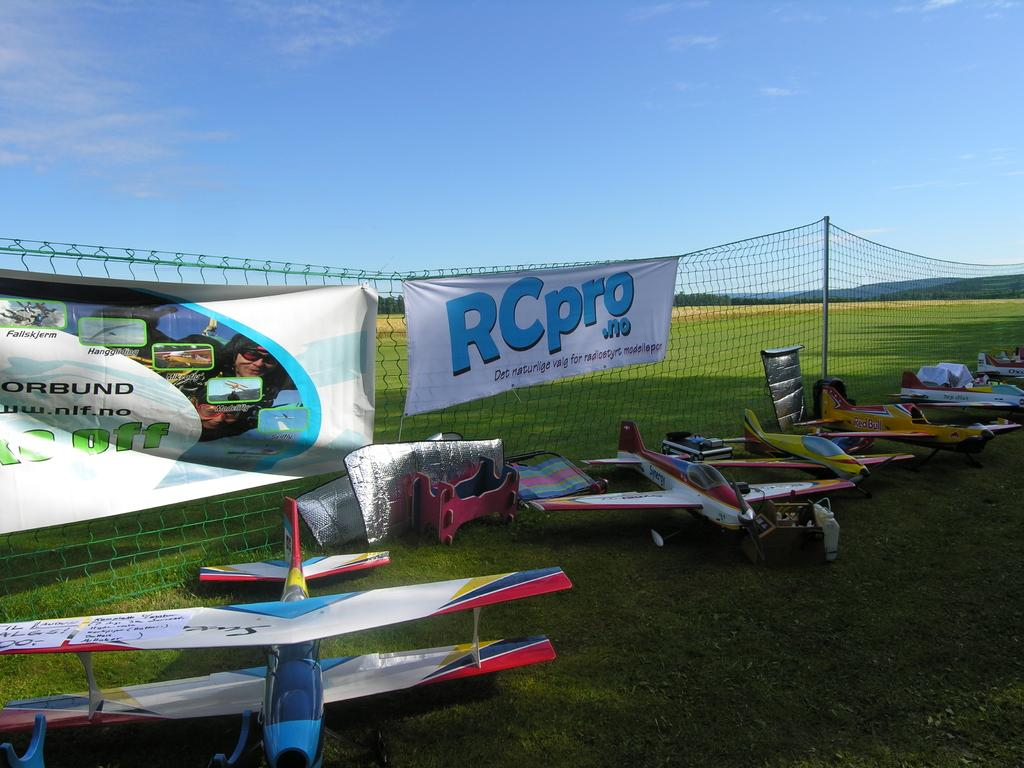<image>
Relay a brief, clear account of the picture shown. A row of scale model airplanes at a RCPro.no event. 